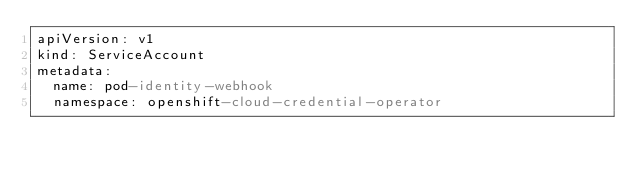<code> <loc_0><loc_0><loc_500><loc_500><_YAML_>apiVersion: v1
kind: ServiceAccount
metadata:
  name: pod-identity-webhook
  namespace: openshift-cloud-credential-operator
</code> 